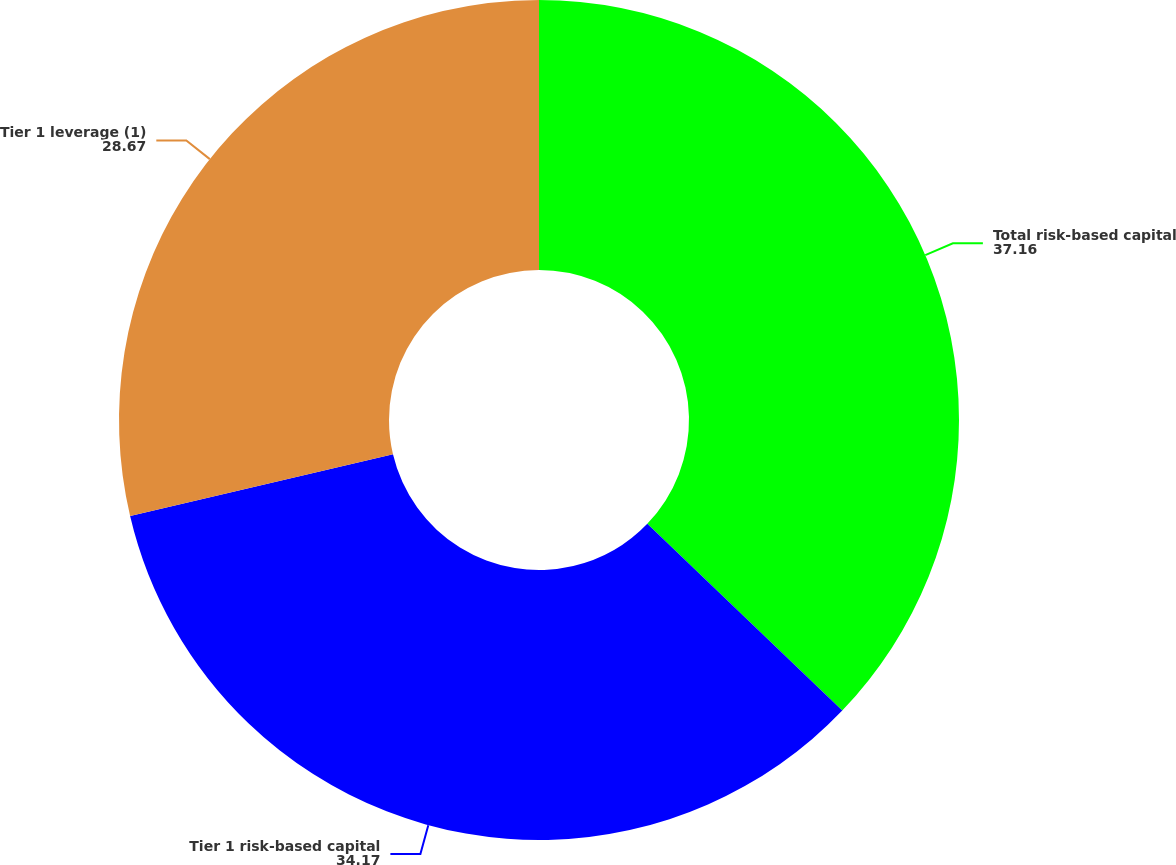<chart> <loc_0><loc_0><loc_500><loc_500><pie_chart><fcel>Total risk-based capital<fcel>Tier 1 risk-based capital<fcel>Tier 1 leverage (1)<nl><fcel>37.16%<fcel>34.17%<fcel>28.67%<nl></chart> 